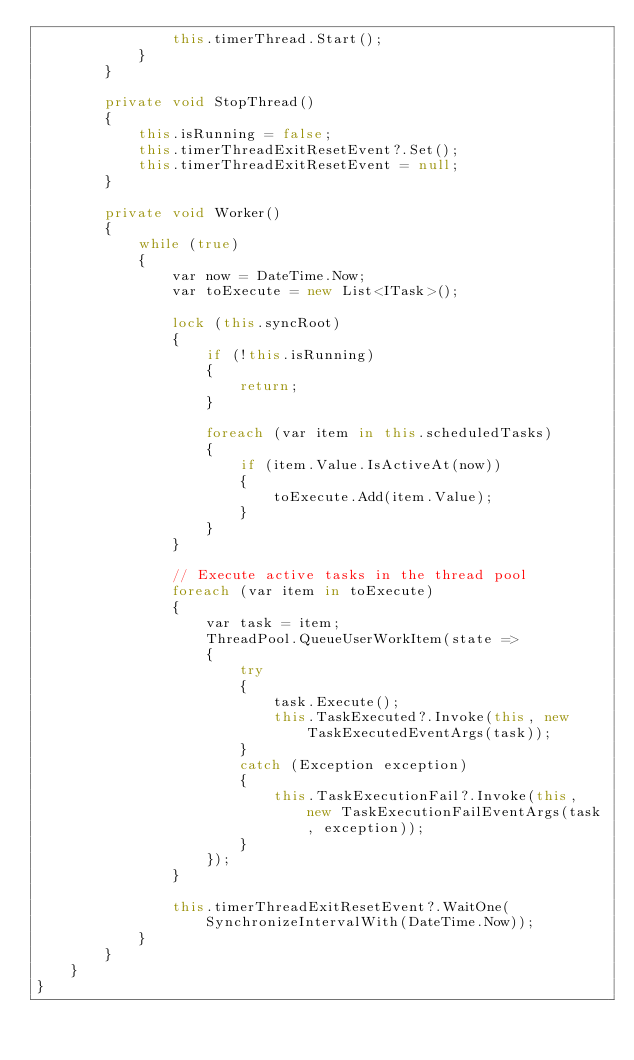Convert code to text. <code><loc_0><loc_0><loc_500><loc_500><_C#_>                this.timerThread.Start();
            }
        }

        private void StopThread()
        {
            this.isRunning = false;
            this.timerThreadExitResetEvent?.Set();
            this.timerThreadExitResetEvent = null;
        }

        private void Worker()
        {
            while (true)
            {
                var now = DateTime.Now;
                var toExecute = new List<ITask>();

                lock (this.syncRoot)
                {
                    if (!this.isRunning)
                    {
                        return;
                    }

                    foreach (var item in this.scheduledTasks)
                    {
                        if (item.Value.IsActiveAt(now))
                        {
                            toExecute.Add(item.Value);
                        }
                    }
                }

                // Execute active tasks in the thread pool
                foreach (var item in toExecute)
                {
                    var task = item;
                    ThreadPool.QueueUserWorkItem(state =>
                    {
                        try
                        {
                            task.Execute();
                            this.TaskExecuted?.Invoke(this, new TaskExecutedEventArgs(task));
                        }
                        catch (Exception exception)
                        {
                            this.TaskExecutionFail?.Invoke(this, new TaskExecutionFailEventArgs(task, exception));
                        }
                    });
                }

                this.timerThreadExitResetEvent?.WaitOne(SynchronizeIntervalWith(DateTime.Now));
            }
        }
    }
}
</code> 